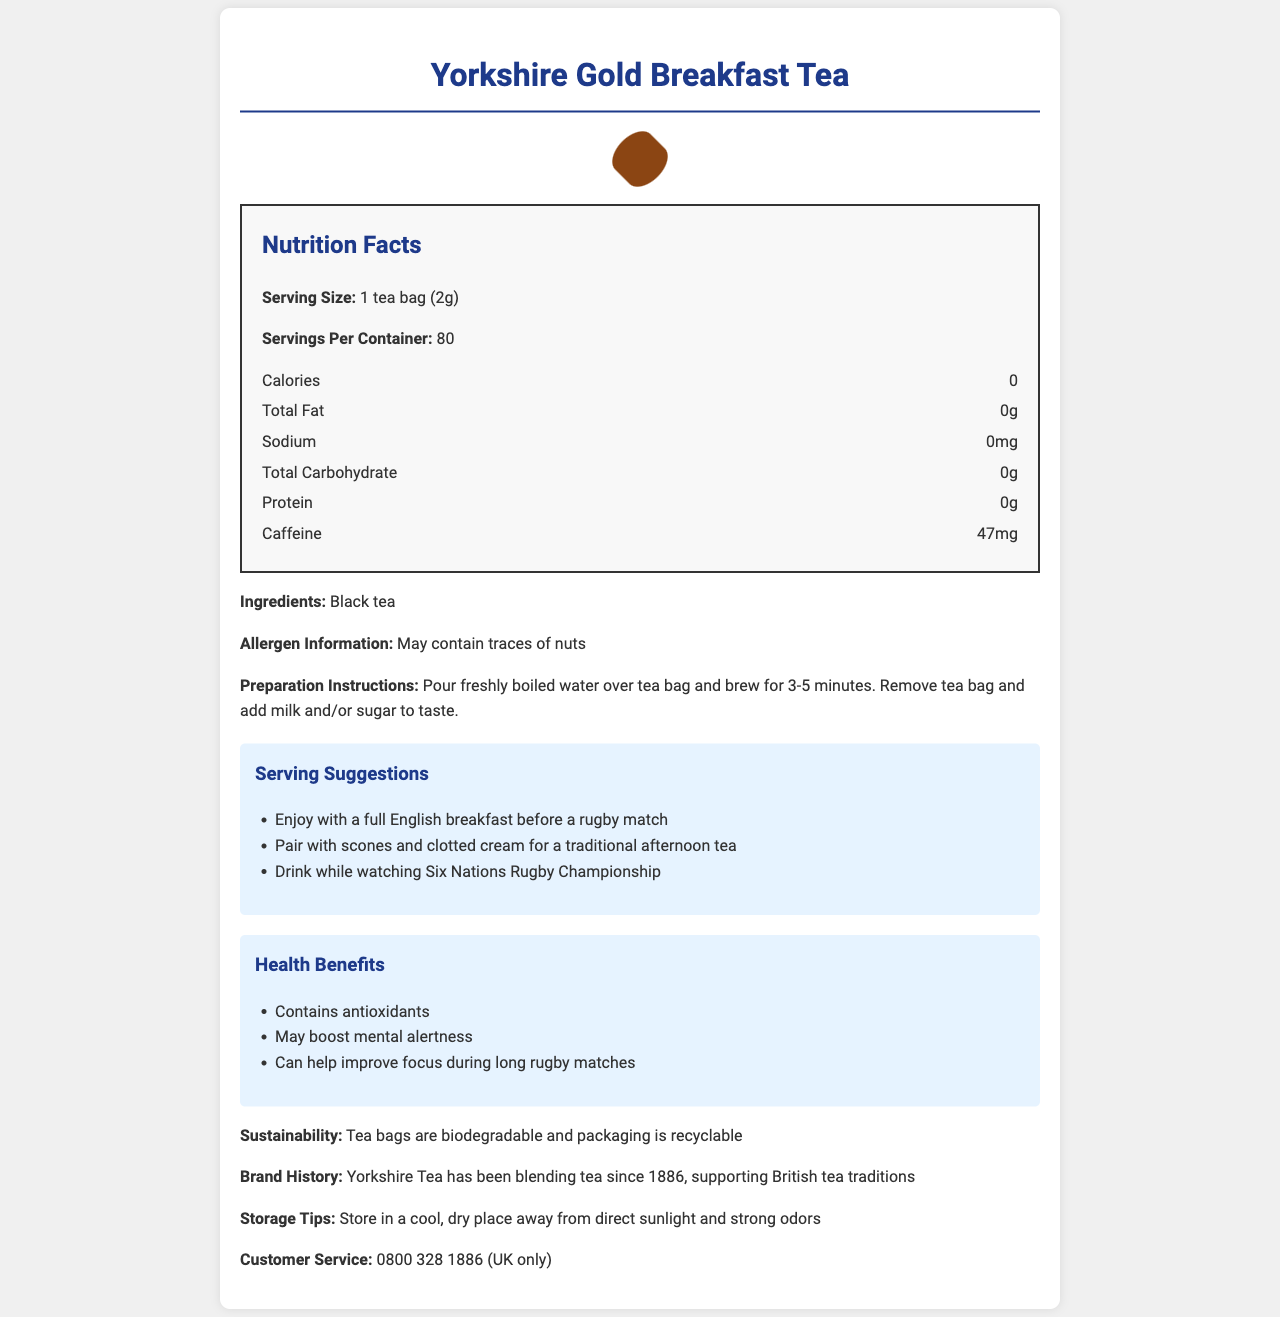what is the serving size for Yorkshire Gold Breakfast Tea? The document specifies that the serving size is "1 tea bag (2g)" under the Nutrition Facts section.
Answer: 1 tea bag (2g) How much caffeine is in each serving of Yorkshire Gold Breakfast Tea? The Nutrition Facts section lists "Caffeine" as 47mg per serving.
Answer: 47mg What ingredients are used in Yorkshire Gold Breakfast Tea? The document lists "Black tea" as the sole ingredient.
Answer: Black tea What is the recommended preparation time for Yorkshire Gold Breakfast Tea? The preparation instructions specify to brew the tea bag for 3-5 minutes.
Answer: 3-5 minutes How many servings are in a container of Yorkshire Gold Breakfast Tea? The document states that there are 80 servings per container.
Answer: 80 Which of the following is NOT a serving suggestion for Yorkshire Gold Breakfast Tea? A. Enjoy with a full English breakfast B. Pair with donuts C. Drink while watching Six Nations Rugby Championship Serving suggestions include: "Enjoy with a full English breakfast," "Pair with scones and clotted cream," and "Drink while watching Six Nations Rugby Championship." Donuts are not mentioned.
Answer: B: Pair with donuts What health benefit is mentioned for Yorkshire Gold Breakfast Tea that could be particularly useful during a rugby match? A. Contains antioxidants B. May boost mental alertness C. Can improve cardiovascular health The health benefits listed include "Contains antioxidants," "May boost mental alertness," and "Can help improve focus during long rugby matches." "May boost mental alertness" is clearly useful during a rugby match.
Answer: B: May boost mental alertness Does Yorkshire Gold Breakfast Tea contain any allergens? The allergen information section states that it "May contain traces of nuts."
Answer: Yes Is Yorkshire Gold Breakfast Tea suitable for someone counting their calorie intake? According to the Nutrition Facts, it contains 0 calories per serving, making it suitable for someone counting calories.
Answer: Yes Summarize the main idea of the document. This summary captures the comprehensive essence of the document, touching on key sections and the overall purpose of providing detailed information about the product.
Answer: The document provides comprehensive information about Yorkshire Gold Breakfast Tea, including its serving size, nutritional content, ingredients, preparation instructions, serving suggestions, health benefits, sustainability, brand history, and customer service contact. It highlights the tea's caffeine content, zero calories, and potential health benefits, such as boosting mental alertness and containing antioxidants. The document also emphasizes the traditional British tea-drinking experience and includes tips for storage and sustainability. When was Yorkshire Tea founded? The document mentions Yorkshire Tea has been blending tea since 1886 but does not specifically state when it was founded. Therefore, we cannot definitively determine its founding year.
Answer: Not enough information 